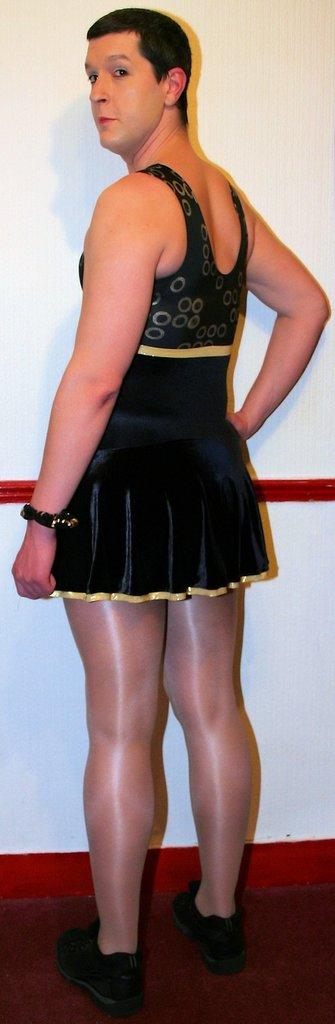What is the person in the image standing on? The person is standing on a red carpet. What is the person wearing in the image? The person is wearing a black dress. What color is the wall in the background of the image? The wall in the background of the image is white. Can you hear the kittens laughing in the image? There are no kittens or sounds present in the image, so it is not possible to hear them laughing. 